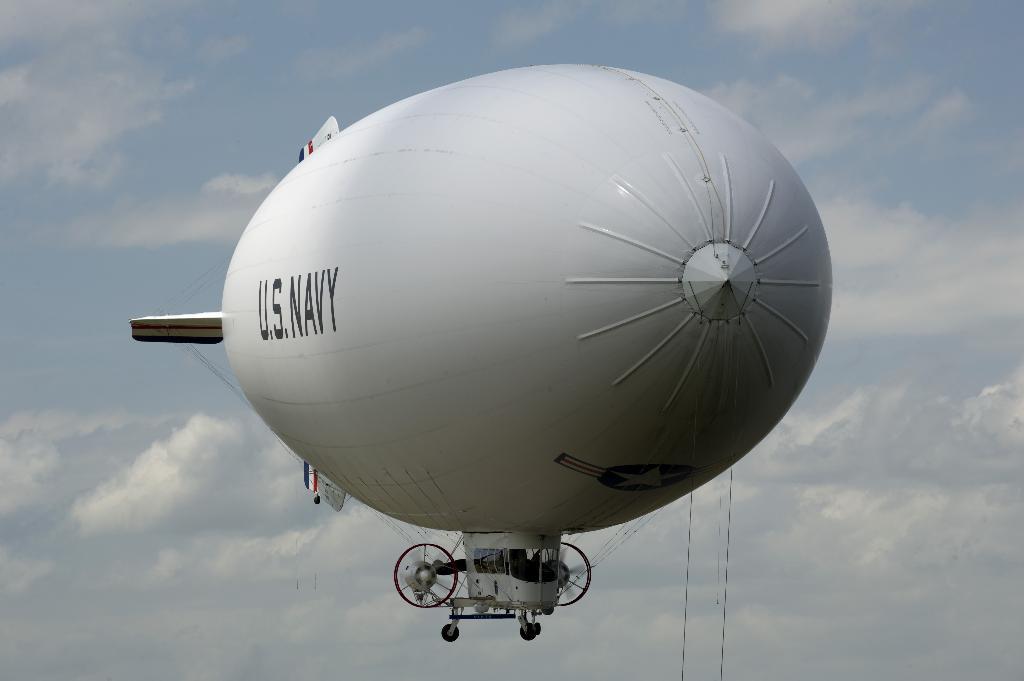Who owns the blimp?
Your answer should be compact. U.s. navy. 